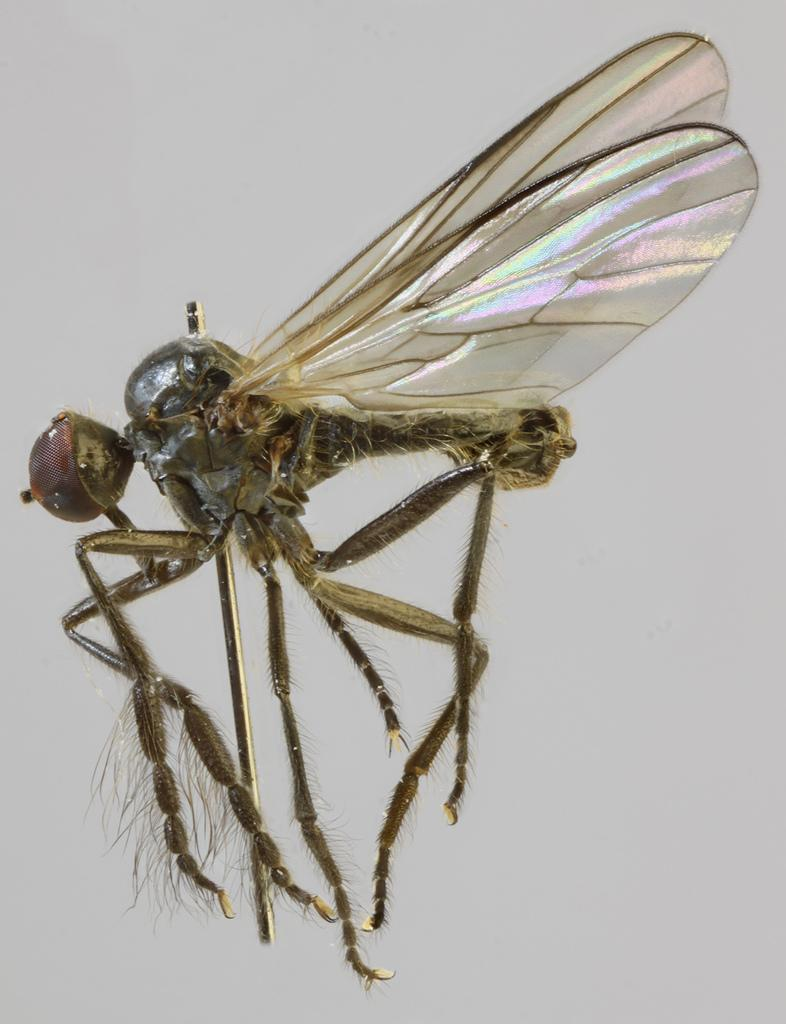What is flying in the air in the image? There is a fly in the air in the image. What type of band is playing music in the image? There is no band present in the image; it only features a fly in the air. 